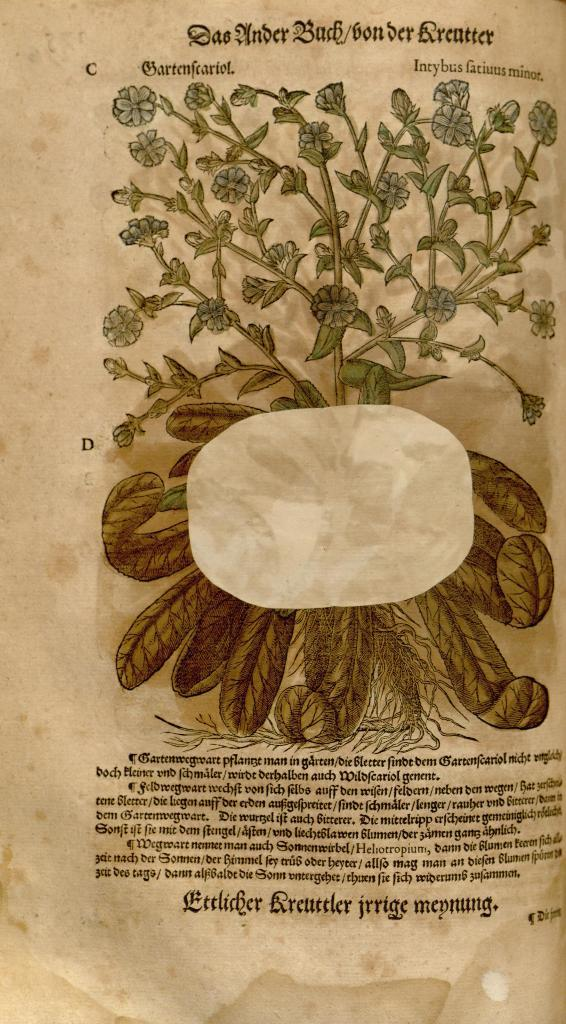What is featured in the picture? There is a poster in the picture. What can be seen on the poster? The poster contains images of flowers on a plant. Is there any text on the poster? Yes, there is text on the poster. What type of meat is being served on the plate in the image? There is no plate or meat present in the image; it only features a poster with images of flowers and text. 